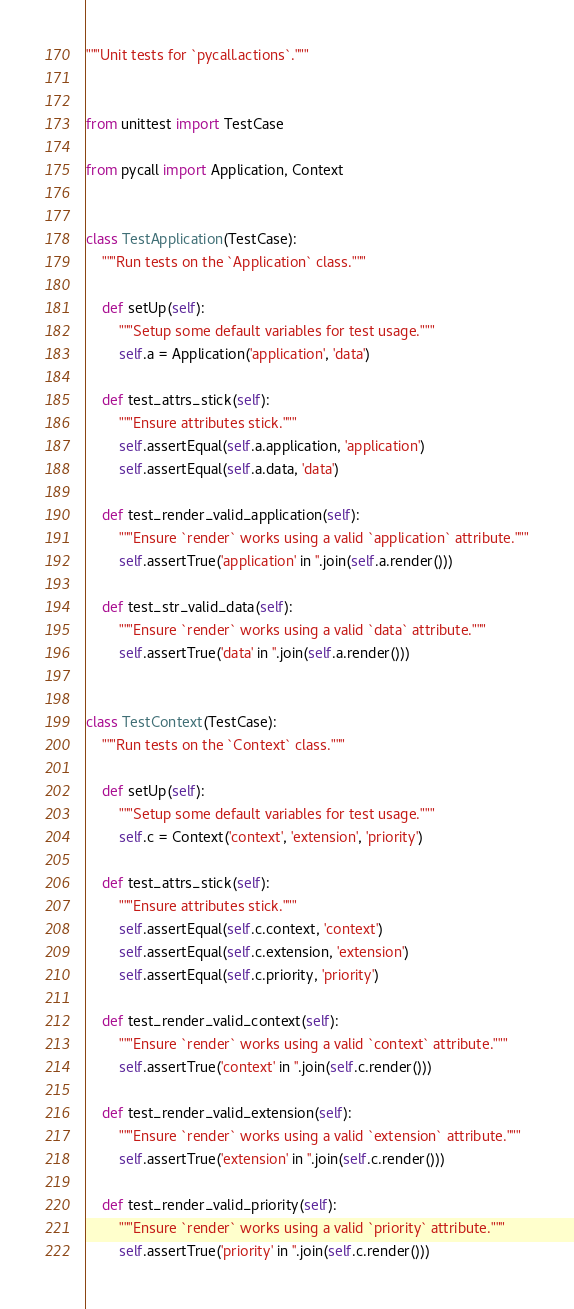Convert code to text. <code><loc_0><loc_0><loc_500><loc_500><_Python_>"""Unit tests for `pycall.actions`."""


from unittest import TestCase

from pycall import Application, Context


class TestApplication(TestCase):
    """Run tests on the `Application` class."""

    def setUp(self):
        """Setup some default variables for test usage."""
        self.a = Application('application', 'data')

    def test_attrs_stick(self):
        """Ensure attributes stick."""
        self.assertEqual(self.a.application, 'application')
        self.assertEqual(self.a.data, 'data')

    def test_render_valid_application(self):
        """Ensure `render` works using a valid `application` attribute."""
        self.assertTrue('application' in ''.join(self.a.render()))

    def test_str_valid_data(self):
        """Ensure `render` works using a valid `data` attribute."""
        self.assertTrue('data' in ''.join(self.a.render()))


class TestContext(TestCase):
    """Run tests on the `Context` class."""

    def setUp(self):
        """Setup some default variables for test usage."""
        self.c = Context('context', 'extension', 'priority')

    def test_attrs_stick(self):
        """Ensure attributes stick."""
        self.assertEqual(self.c.context, 'context')
        self.assertEqual(self.c.extension, 'extension')
        self.assertEqual(self.c.priority, 'priority')

    def test_render_valid_context(self):
        """Ensure `render` works using a valid `context` attribute."""
        self.assertTrue('context' in ''.join(self.c.render()))

    def test_render_valid_extension(self):
        """Ensure `render` works using a valid `extension` attribute."""
        self.assertTrue('extension' in ''.join(self.c.render()))

    def test_render_valid_priority(self):
        """Ensure `render` works using a valid `priority` attribute."""
        self.assertTrue('priority' in ''.join(self.c.render()))
</code> 